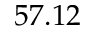Convert formula to latex. <formula><loc_0><loc_0><loc_500><loc_500>5 7 . 1 2</formula> 